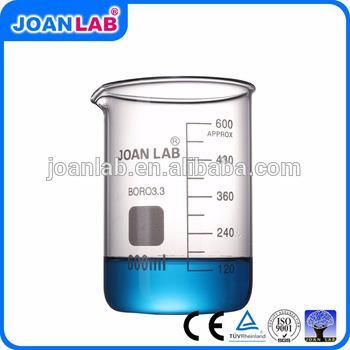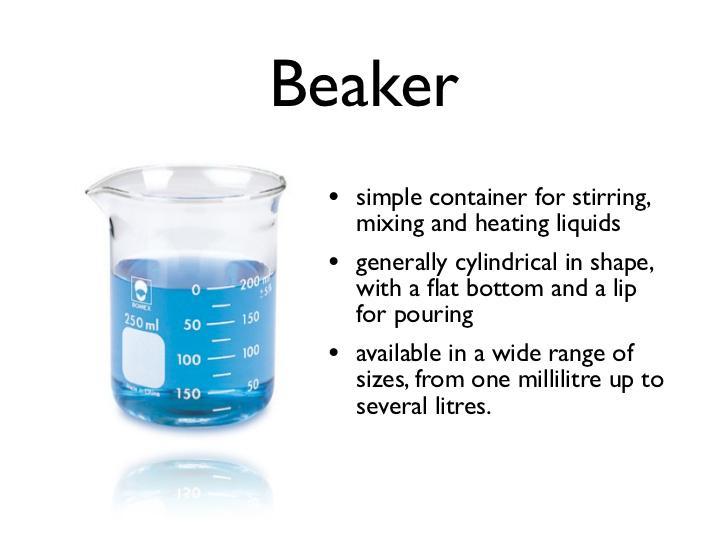The first image is the image on the left, the second image is the image on the right. Considering the images on both sides, is "There is exactly one empty beaker." valid? Answer yes or no. No. The first image is the image on the left, the second image is the image on the right. Analyze the images presented: Is the assertion "The right image shows multiple beakers." valid? Answer yes or no. No. 